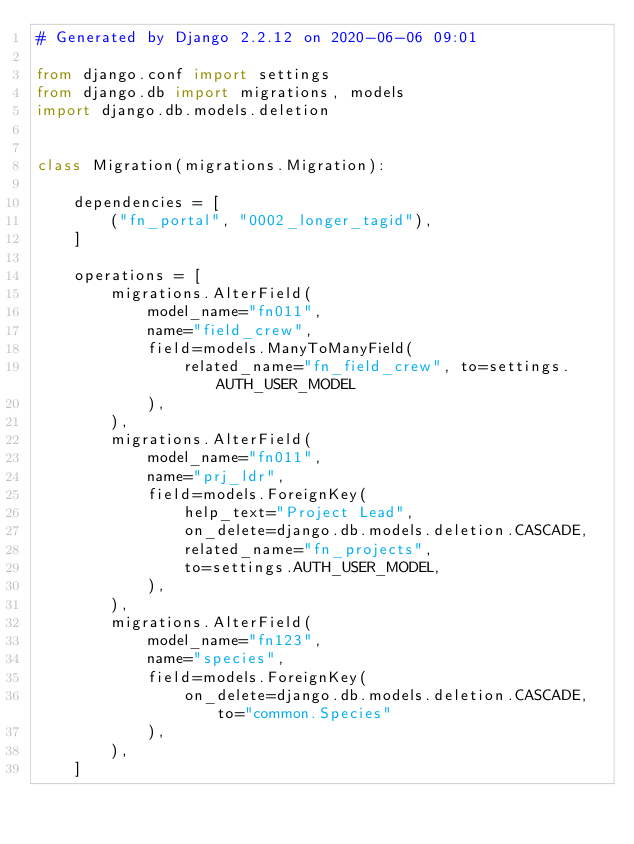<code> <loc_0><loc_0><loc_500><loc_500><_Python_># Generated by Django 2.2.12 on 2020-06-06 09:01

from django.conf import settings
from django.db import migrations, models
import django.db.models.deletion


class Migration(migrations.Migration):

    dependencies = [
        ("fn_portal", "0002_longer_tagid"),
    ]

    operations = [
        migrations.AlterField(
            model_name="fn011",
            name="field_crew",
            field=models.ManyToManyField(
                related_name="fn_field_crew", to=settings.AUTH_USER_MODEL
            ),
        ),
        migrations.AlterField(
            model_name="fn011",
            name="prj_ldr",
            field=models.ForeignKey(
                help_text="Project Lead",
                on_delete=django.db.models.deletion.CASCADE,
                related_name="fn_projects",
                to=settings.AUTH_USER_MODEL,
            ),
        ),
        migrations.AlterField(
            model_name="fn123",
            name="species",
            field=models.ForeignKey(
                on_delete=django.db.models.deletion.CASCADE, to="common.Species"
            ),
        ),
    ]
</code> 